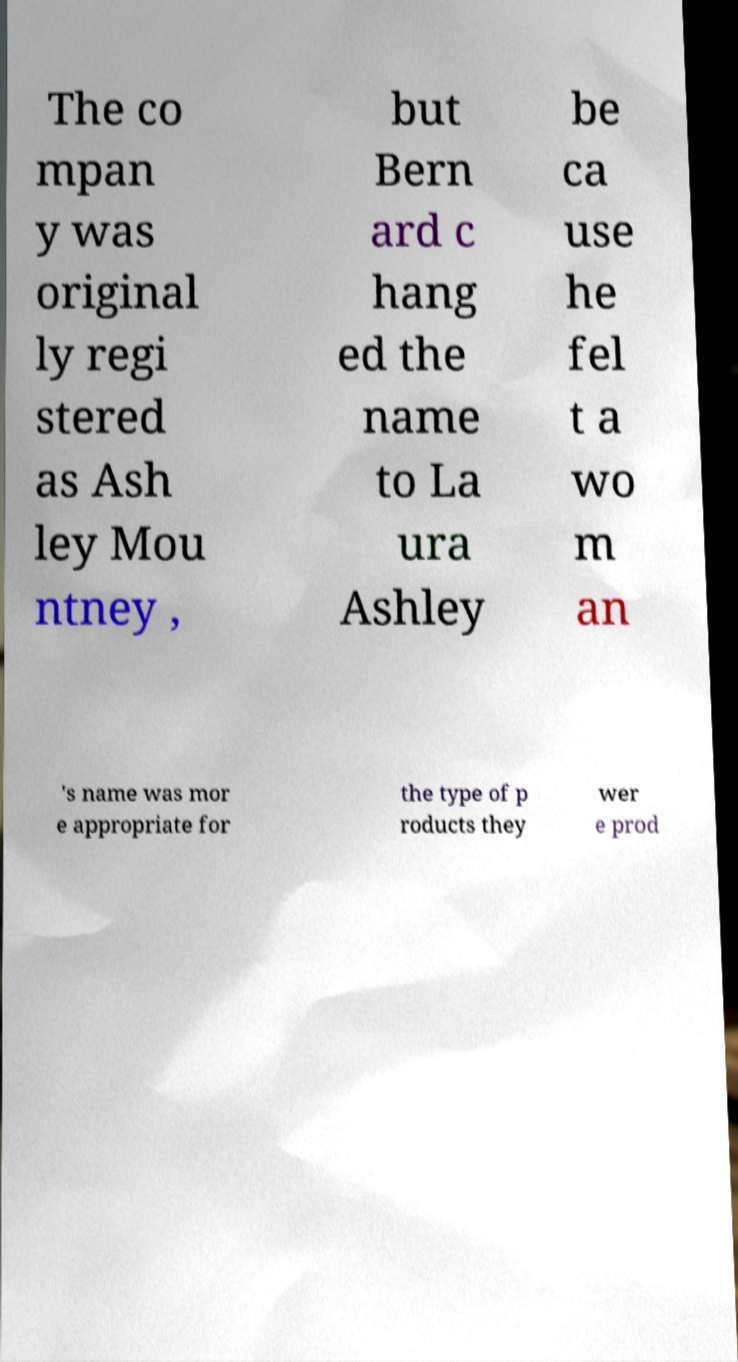Can you explain why a woman's name was considered more appropriate for the company? During the time when Bernard Ashley rebranded the company, consumer perceptions were heavily influenced by the personal touch and femininity associated with women's names. This was particularly impactful in industries like fashion and home decor, which were the company's focus. The name 'Laura Ashley' likely conveyed a sense of style, elegance, and approachability that helped the brand resonate with its target audience. 